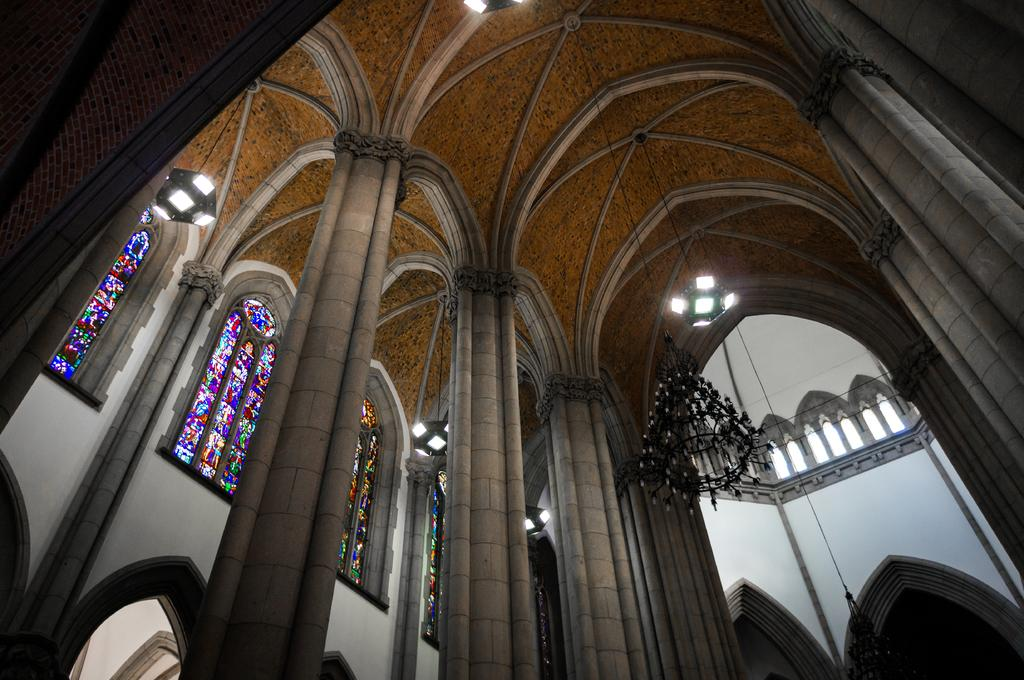What type of location is depicted in the image? The image shows an inside view of a building. What can be seen at the top of the image? There are lights visible at the top of the image. What decorative feature is hanging from the roof? A chandelier is hanging from the roof. What architectural element is present on the left side of the image? There are many windows on the left side of the image. What color is the gold brick used to build the wall in the image? There is no gold brick present in the image; it shows an inside view of a building with lights, a chandelier, and windows. 